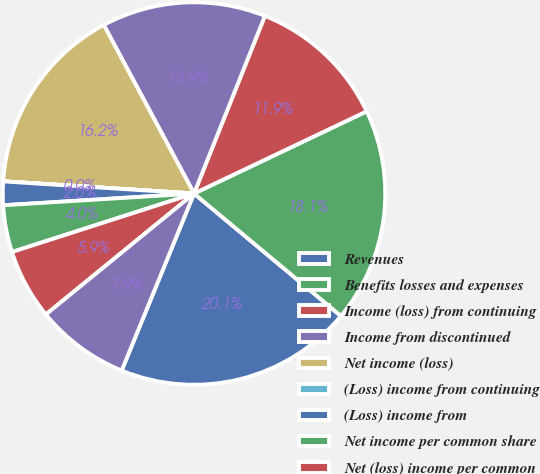Convert chart to OTSL. <chart><loc_0><loc_0><loc_500><loc_500><pie_chart><fcel>Revenues<fcel>Benefits losses and expenses<fcel>Income (loss) from continuing<fcel>Income from discontinued<fcel>Net income (loss)<fcel>(Loss) income from continuing<fcel>(Loss) income from<fcel>Net income per common share<fcel>Net (loss) income per common<fcel>Weighted average common shares<nl><fcel>20.12%<fcel>18.14%<fcel>11.89%<fcel>13.87%<fcel>16.16%<fcel>0.01%<fcel>1.99%<fcel>3.97%<fcel>5.95%<fcel>7.93%<nl></chart> 